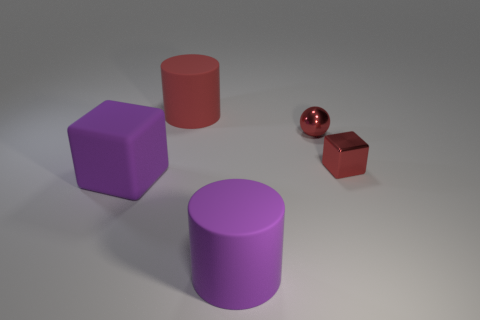Add 5 tiny blue balls. How many objects exist? 10 Subtract 1 red balls. How many objects are left? 4 Subtract all cubes. How many objects are left? 3 Subtract 1 cylinders. How many cylinders are left? 1 Subtract all yellow balls. Subtract all blue cylinders. How many balls are left? 1 Subtract all purple cylinders. How many blue balls are left? 0 Subtract all yellow metal cubes. Subtract all red shiny objects. How many objects are left? 3 Add 4 matte things. How many matte things are left? 7 Add 4 cyan matte cylinders. How many cyan matte cylinders exist? 4 Subtract all red cubes. How many cubes are left? 1 